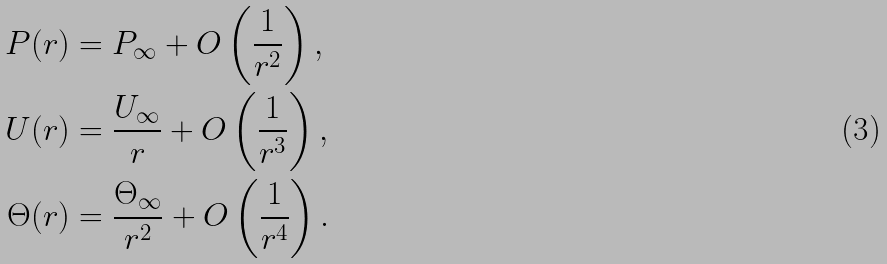Convert formula to latex. <formula><loc_0><loc_0><loc_500><loc_500>P ( r ) & = P _ { \infty } + O \left ( \frac { 1 } { r ^ { 2 } } \right ) , \\ U ( r ) & = \frac { U _ { \infty } } { r } + O \left ( \frac { 1 } { r ^ { 3 } } \right ) , \\ \Theta ( r ) & = \frac { \Theta _ { \infty } } { r ^ { 2 } } + O \left ( \frac { 1 } { r ^ { 4 } } \right ) .</formula> 